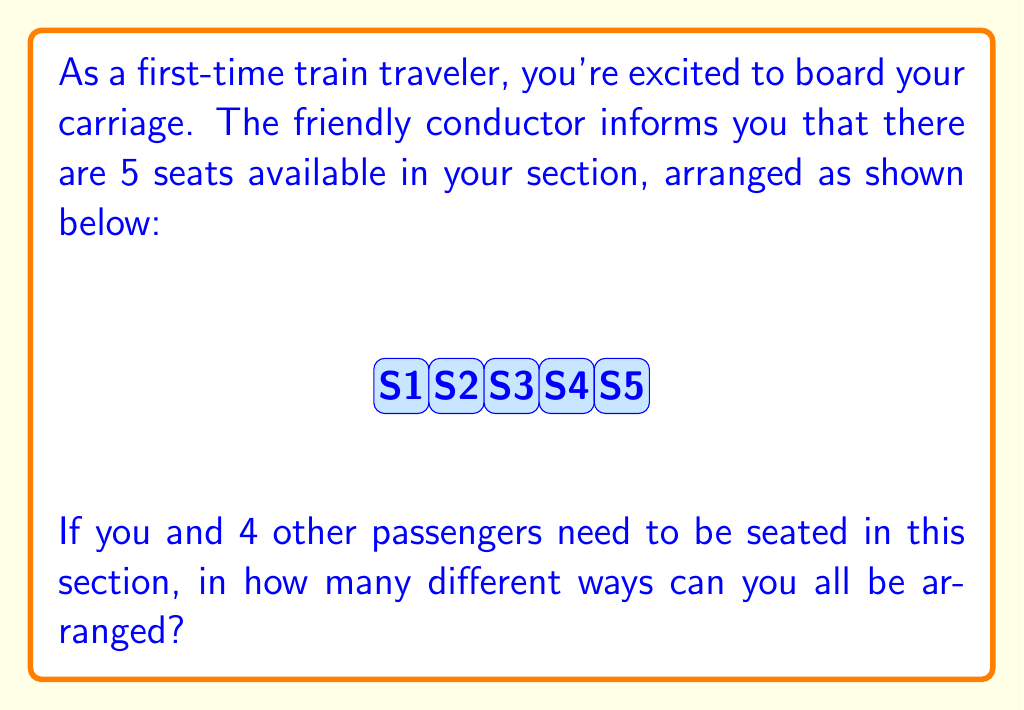Show me your answer to this math problem. Let's approach this step-by-step:

1) This is a permutation problem. We need to arrange 5 people in 5 seats.

2) For the first seat, we have 5 choices (any of the 5 people can sit there).

3) For the second seat, we have 4 choices (one person is already seated).

4) For the third seat, we have 3 choices.

5) For the fourth seat, we have 2 choices.

6) For the last seat, we only have 1 choice (the last remaining person).

7) According to the multiplication principle, we multiply these numbers together:

   $$ 5 \times 4 \times 3 \times 2 \times 1 $$

8) This is also known as 5 factorial, written as 5!

9) Therefore, the number of different seating arrangements is:

   $$ 5! = 5 \times 4 \times 3 \times 2 \times 1 = 120 $$

So, there are 120 different ways to arrange 5 passengers in these 5 seats.
Answer: 120 